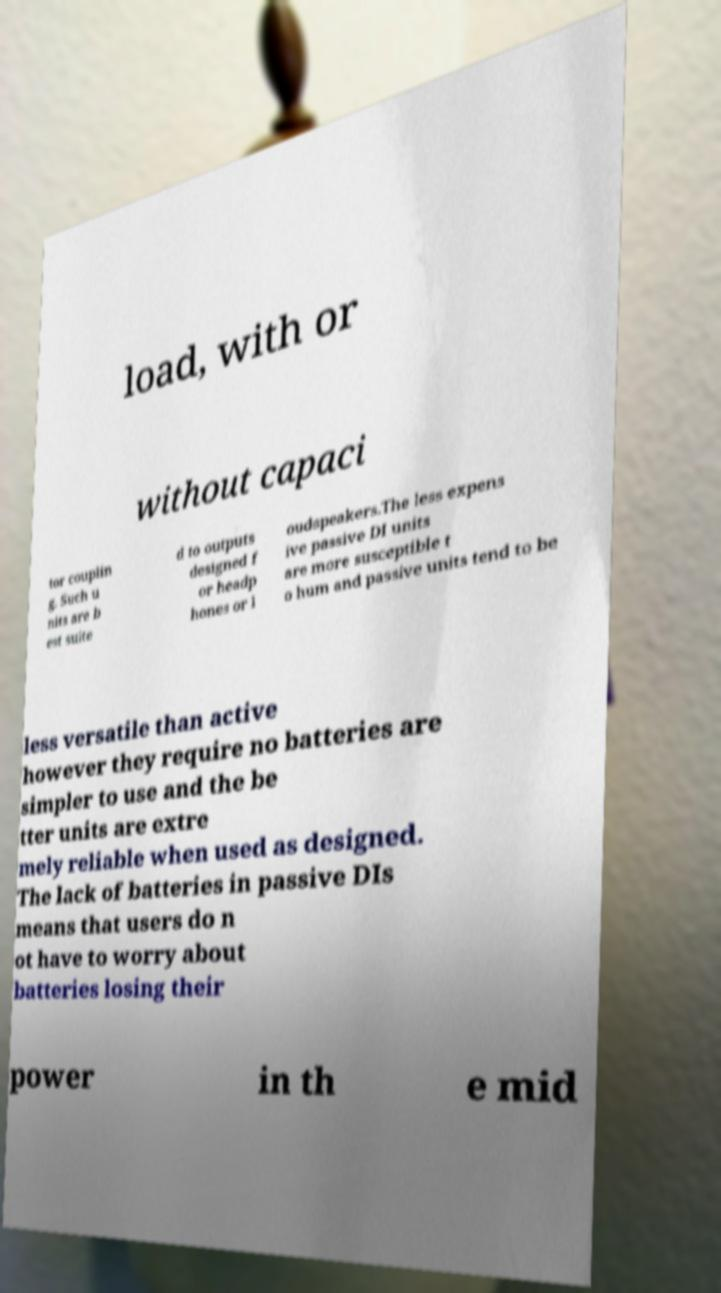Could you extract and type out the text from this image? load, with or without capaci tor couplin g. Such u nits are b est suite d to outputs designed f or headp hones or l oudspeakers.The less expens ive passive DI units are more susceptible t o hum and passive units tend to be less versatile than active however they require no batteries are simpler to use and the be tter units are extre mely reliable when used as designed. The lack of batteries in passive DIs means that users do n ot have to worry about batteries losing their power in th e mid 